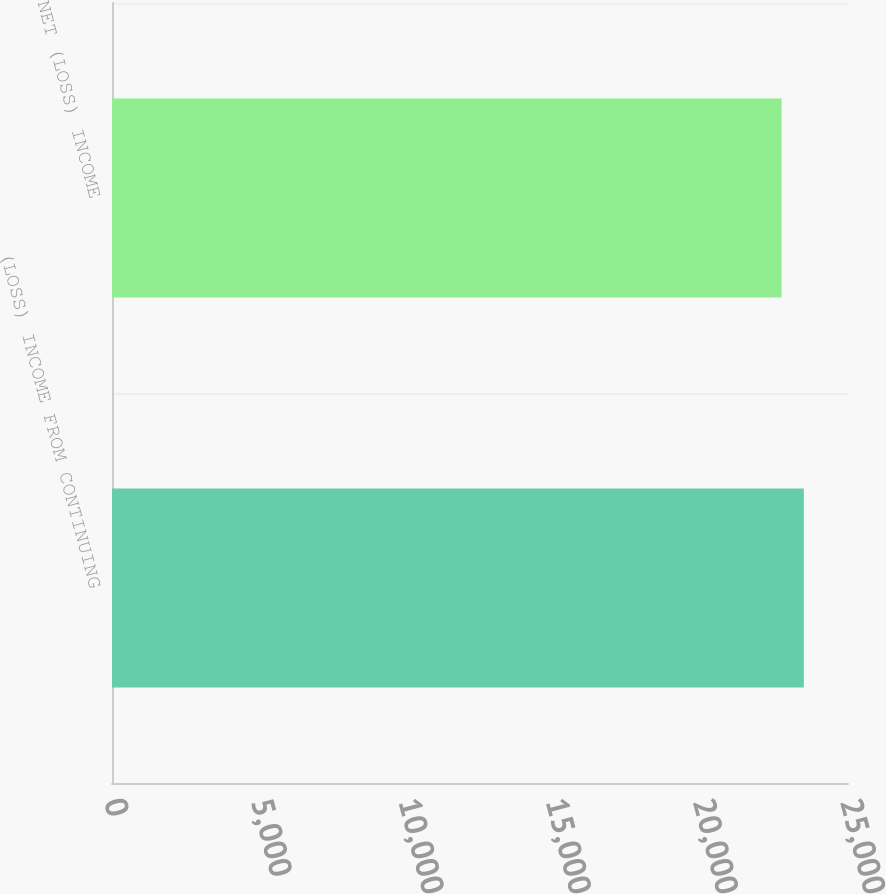<chart> <loc_0><loc_0><loc_500><loc_500><bar_chart><fcel>(LOSS) INCOME FROM CONTINUING<fcel>NET (LOSS) INCOME<nl><fcel>23499<fcel>22742<nl></chart> 